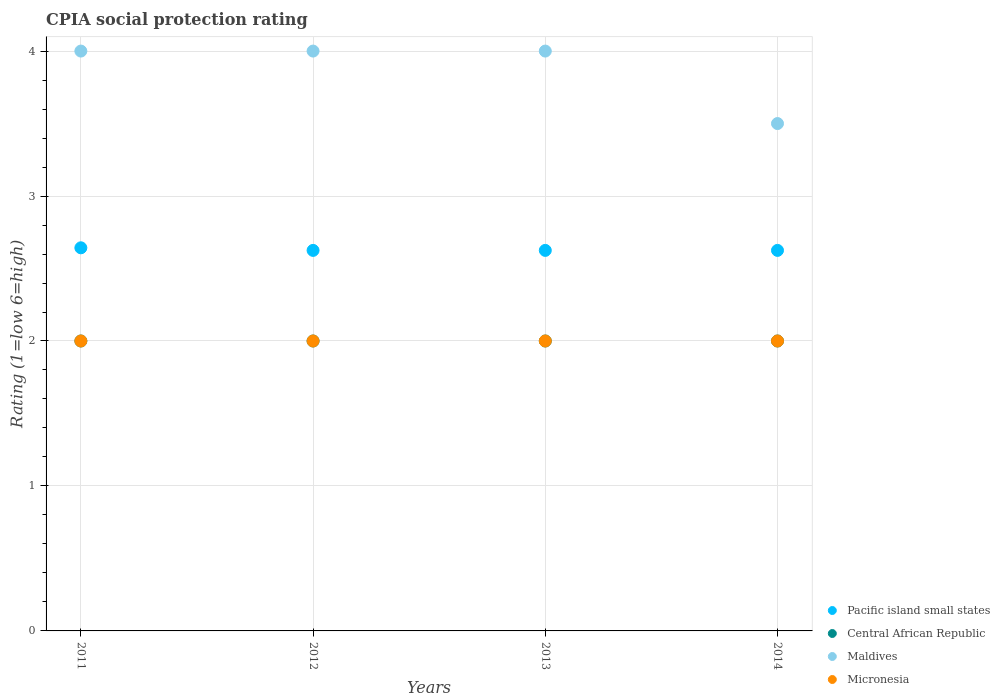How many different coloured dotlines are there?
Make the answer very short. 4. What is the CPIA rating in Micronesia in 2012?
Offer a terse response. 2. Across all years, what is the maximum CPIA rating in Central African Republic?
Make the answer very short. 2. In which year was the CPIA rating in Maldives minimum?
Ensure brevity in your answer.  2014. What is the difference between the CPIA rating in Central African Republic in 2012 and that in 2014?
Keep it short and to the point. 0. What is the difference between the CPIA rating in Micronesia in 2011 and the CPIA rating in Pacific island small states in 2012?
Provide a short and direct response. -0.62. What is the average CPIA rating in Central African Republic per year?
Your response must be concise. 2. In the year 2014, what is the difference between the CPIA rating in Micronesia and CPIA rating in Pacific island small states?
Ensure brevity in your answer.  -0.62. In how many years, is the CPIA rating in Pacific island small states greater than 1.4?
Provide a short and direct response. 4. What is the ratio of the CPIA rating in Micronesia in 2012 to that in 2014?
Make the answer very short. 1. Is the CPIA rating in Central African Republic in 2011 less than that in 2013?
Provide a short and direct response. No. What is the difference between the highest and the second highest CPIA rating in Central African Republic?
Your response must be concise. 0. In how many years, is the CPIA rating in Maldives greater than the average CPIA rating in Maldives taken over all years?
Make the answer very short. 3. Is it the case that in every year, the sum of the CPIA rating in Central African Republic and CPIA rating in Micronesia  is greater than the sum of CPIA rating in Pacific island small states and CPIA rating in Maldives?
Give a very brief answer. No. Is it the case that in every year, the sum of the CPIA rating in Pacific island small states and CPIA rating in Central African Republic  is greater than the CPIA rating in Micronesia?
Your answer should be compact. Yes. Is the CPIA rating in Micronesia strictly greater than the CPIA rating in Pacific island small states over the years?
Offer a terse response. No. How many dotlines are there?
Provide a short and direct response. 4. Does the graph contain grids?
Offer a very short reply. Yes. Where does the legend appear in the graph?
Make the answer very short. Bottom right. How are the legend labels stacked?
Offer a very short reply. Vertical. What is the title of the graph?
Your answer should be very brief. CPIA social protection rating. What is the label or title of the Y-axis?
Provide a short and direct response. Rating (1=low 6=high). What is the Rating (1=low 6=high) of Pacific island small states in 2011?
Your answer should be very brief. 2.64. What is the Rating (1=low 6=high) of Central African Republic in 2011?
Keep it short and to the point. 2. What is the Rating (1=low 6=high) of Maldives in 2011?
Offer a terse response. 4. What is the Rating (1=low 6=high) of Micronesia in 2011?
Make the answer very short. 2. What is the Rating (1=low 6=high) in Pacific island small states in 2012?
Keep it short and to the point. 2.62. What is the Rating (1=low 6=high) of Central African Republic in 2012?
Give a very brief answer. 2. What is the Rating (1=low 6=high) in Pacific island small states in 2013?
Your answer should be very brief. 2.62. What is the Rating (1=low 6=high) of Micronesia in 2013?
Keep it short and to the point. 2. What is the Rating (1=low 6=high) of Pacific island small states in 2014?
Your response must be concise. 2.62. What is the Rating (1=low 6=high) in Micronesia in 2014?
Offer a terse response. 2. Across all years, what is the maximum Rating (1=low 6=high) in Pacific island small states?
Make the answer very short. 2.64. Across all years, what is the minimum Rating (1=low 6=high) of Pacific island small states?
Give a very brief answer. 2.62. Across all years, what is the minimum Rating (1=low 6=high) in Central African Republic?
Offer a very short reply. 2. Across all years, what is the minimum Rating (1=low 6=high) in Micronesia?
Your answer should be very brief. 2. What is the total Rating (1=low 6=high) of Pacific island small states in the graph?
Make the answer very short. 10.52. What is the difference between the Rating (1=low 6=high) in Pacific island small states in 2011 and that in 2012?
Make the answer very short. 0.02. What is the difference between the Rating (1=low 6=high) of Maldives in 2011 and that in 2012?
Offer a very short reply. 0. What is the difference between the Rating (1=low 6=high) of Micronesia in 2011 and that in 2012?
Ensure brevity in your answer.  0. What is the difference between the Rating (1=low 6=high) in Pacific island small states in 2011 and that in 2013?
Your answer should be very brief. 0.02. What is the difference between the Rating (1=low 6=high) of Central African Republic in 2011 and that in 2013?
Make the answer very short. 0. What is the difference between the Rating (1=low 6=high) of Pacific island small states in 2011 and that in 2014?
Make the answer very short. 0.02. What is the difference between the Rating (1=low 6=high) of Micronesia in 2011 and that in 2014?
Keep it short and to the point. 0. What is the difference between the Rating (1=low 6=high) of Central African Republic in 2012 and that in 2013?
Offer a terse response. 0. What is the difference between the Rating (1=low 6=high) of Maldives in 2012 and that in 2013?
Your response must be concise. 0. What is the difference between the Rating (1=low 6=high) of Micronesia in 2012 and that in 2013?
Offer a terse response. 0. What is the difference between the Rating (1=low 6=high) in Central African Republic in 2012 and that in 2014?
Offer a very short reply. 0. What is the difference between the Rating (1=low 6=high) in Micronesia in 2013 and that in 2014?
Keep it short and to the point. 0. What is the difference between the Rating (1=low 6=high) in Pacific island small states in 2011 and the Rating (1=low 6=high) in Central African Republic in 2012?
Give a very brief answer. 0.64. What is the difference between the Rating (1=low 6=high) in Pacific island small states in 2011 and the Rating (1=low 6=high) in Maldives in 2012?
Provide a succinct answer. -1.36. What is the difference between the Rating (1=low 6=high) of Pacific island small states in 2011 and the Rating (1=low 6=high) of Micronesia in 2012?
Make the answer very short. 0.64. What is the difference between the Rating (1=low 6=high) in Central African Republic in 2011 and the Rating (1=low 6=high) in Maldives in 2012?
Offer a very short reply. -2. What is the difference between the Rating (1=low 6=high) of Pacific island small states in 2011 and the Rating (1=low 6=high) of Central African Republic in 2013?
Offer a terse response. 0.64. What is the difference between the Rating (1=low 6=high) in Pacific island small states in 2011 and the Rating (1=low 6=high) in Maldives in 2013?
Keep it short and to the point. -1.36. What is the difference between the Rating (1=low 6=high) in Pacific island small states in 2011 and the Rating (1=low 6=high) in Micronesia in 2013?
Offer a terse response. 0.64. What is the difference between the Rating (1=low 6=high) in Central African Republic in 2011 and the Rating (1=low 6=high) in Micronesia in 2013?
Give a very brief answer. 0. What is the difference between the Rating (1=low 6=high) in Maldives in 2011 and the Rating (1=low 6=high) in Micronesia in 2013?
Make the answer very short. 2. What is the difference between the Rating (1=low 6=high) in Pacific island small states in 2011 and the Rating (1=low 6=high) in Central African Republic in 2014?
Provide a short and direct response. 0.64. What is the difference between the Rating (1=low 6=high) in Pacific island small states in 2011 and the Rating (1=low 6=high) in Maldives in 2014?
Your answer should be very brief. -0.86. What is the difference between the Rating (1=low 6=high) in Pacific island small states in 2011 and the Rating (1=low 6=high) in Micronesia in 2014?
Offer a terse response. 0.64. What is the difference between the Rating (1=low 6=high) in Maldives in 2011 and the Rating (1=low 6=high) in Micronesia in 2014?
Provide a succinct answer. 2. What is the difference between the Rating (1=low 6=high) in Pacific island small states in 2012 and the Rating (1=low 6=high) in Maldives in 2013?
Give a very brief answer. -1.38. What is the difference between the Rating (1=low 6=high) in Central African Republic in 2012 and the Rating (1=low 6=high) in Micronesia in 2013?
Offer a terse response. 0. What is the difference between the Rating (1=low 6=high) in Maldives in 2012 and the Rating (1=low 6=high) in Micronesia in 2013?
Keep it short and to the point. 2. What is the difference between the Rating (1=low 6=high) in Pacific island small states in 2012 and the Rating (1=low 6=high) in Maldives in 2014?
Give a very brief answer. -0.88. What is the difference between the Rating (1=low 6=high) of Central African Republic in 2012 and the Rating (1=low 6=high) of Maldives in 2014?
Ensure brevity in your answer.  -1.5. What is the difference between the Rating (1=low 6=high) of Central African Republic in 2012 and the Rating (1=low 6=high) of Micronesia in 2014?
Keep it short and to the point. 0. What is the difference between the Rating (1=low 6=high) of Maldives in 2012 and the Rating (1=low 6=high) of Micronesia in 2014?
Offer a very short reply. 2. What is the difference between the Rating (1=low 6=high) in Pacific island small states in 2013 and the Rating (1=low 6=high) in Maldives in 2014?
Provide a short and direct response. -0.88. What is the difference between the Rating (1=low 6=high) of Pacific island small states in 2013 and the Rating (1=low 6=high) of Micronesia in 2014?
Keep it short and to the point. 0.62. What is the difference between the Rating (1=low 6=high) of Central African Republic in 2013 and the Rating (1=low 6=high) of Maldives in 2014?
Your response must be concise. -1.5. What is the average Rating (1=low 6=high) in Pacific island small states per year?
Offer a very short reply. 2.63. What is the average Rating (1=low 6=high) of Central African Republic per year?
Offer a very short reply. 2. What is the average Rating (1=low 6=high) in Maldives per year?
Offer a very short reply. 3.88. What is the average Rating (1=low 6=high) of Micronesia per year?
Your response must be concise. 2. In the year 2011, what is the difference between the Rating (1=low 6=high) in Pacific island small states and Rating (1=low 6=high) in Central African Republic?
Provide a short and direct response. 0.64. In the year 2011, what is the difference between the Rating (1=low 6=high) of Pacific island small states and Rating (1=low 6=high) of Maldives?
Provide a short and direct response. -1.36. In the year 2011, what is the difference between the Rating (1=low 6=high) of Pacific island small states and Rating (1=low 6=high) of Micronesia?
Your response must be concise. 0.64. In the year 2011, what is the difference between the Rating (1=low 6=high) of Central African Republic and Rating (1=low 6=high) of Micronesia?
Provide a succinct answer. 0. In the year 2012, what is the difference between the Rating (1=low 6=high) of Pacific island small states and Rating (1=low 6=high) of Maldives?
Provide a short and direct response. -1.38. In the year 2012, what is the difference between the Rating (1=low 6=high) in Pacific island small states and Rating (1=low 6=high) in Micronesia?
Your answer should be very brief. 0.62. In the year 2012, what is the difference between the Rating (1=low 6=high) in Central African Republic and Rating (1=low 6=high) in Micronesia?
Your response must be concise. 0. In the year 2012, what is the difference between the Rating (1=low 6=high) of Maldives and Rating (1=low 6=high) of Micronesia?
Provide a short and direct response. 2. In the year 2013, what is the difference between the Rating (1=low 6=high) in Pacific island small states and Rating (1=low 6=high) in Maldives?
Keep it short and to the point. -1.38. In the year 2013, what is the difference between the Rating (1=low 6=high) of Pacific island small states and Rating (1=low 6=high) of Micronesia?
Offer a terse response. 0.62. In the year 2013, what is the difference between the Rating (1=low 6=high) of Central African Republic and Rating (1=low 6=high) of Maldives?
Give a very brief answer. -2. In the year 2013, what is the difference between the Rating (1=low 6=high) in Maldives and Rating (1=low 6=high) in Micronesia?
Make the answer very short. 2. In the year 2014, what is the difference between the Rating (1=low 6=high) of Pacific island small states and Rating (1=low 6=high) of Maldives?
Offer a very short reply. -0.88. In the year 2014, what is the difference between the Rating (1=low 6=high) of Pacific island small states and Rating (1=low 6=high) of Micronesia?
Give a very brief answer. 0.62. In the year 2014, what is the difference between the Rating (1=low 6=high) of Central African Republic and Rating (1=low 6=high) of Maldives?
Your answer should be very brief. -1.5. What is the ratio of the Rating (1=low 6=high) in Pacific island small states in 2011 to that in 2012?
Provide a succinct answer. 1.01. What is the ratio of the Rating (1=low 6=high) in Central African Republic in 2011 to that in 2012?
Give a very brief answer. 1. What is the ratio of the Rating (1=low 6=high) of Micronesia in 2011 to that in 2012?
Your response must be concise. 1. What is the ratio of the Rating (1=low 6=high) in Pacific island small states in 2011 to that in 2013?
Ensure brevity in your answer.  1.01. What is the ratio of the Rating (1=low 6=high) in Micronesia in 2011 to that in 2013?
Make the answer very short. 1. What is the ratio of the Rating (1=low 6=high) in Pacific island small states in 2011 to that in 2014?
Provide a short and direct response. 1.01. What is the ratio of the Rating (1=low 6=high) in Maldives in 2011 to that in 2014?
Offer a very short reply. 1.14. What is the ratio of the Rating (1=low 6=high) of Pacific island small states in 2012 to that in 2013?
Offer a terse response. 1. What is the ratio of the Rating (1=low 6=high) of Central African Republic in 2012 to that in 2013?
Provide a succinct answer. 1. What is the ratio of the Rating (1=low 6=high) of Maldives in 2012 to that in 2013?
Keep it short and to the point. 1. What is the ratio of the Rating (1=low 6=high) in Pacific island small states in 2012 to that in 2014?
Keep it short and to the point. 1. What is the ratio of the Rating (1=low 6=high) in Micronesia in 2012 to that in 2014?
Offer a very short reply. 1. What is the ratio of the Rating (1=low 6=high) in Pacific island small states in 2013 to that in 2014?
Ensure brevity in your answer.  1. What is the difference between the highest and the second highest Rating (1=low 6=high) in Pacific island small states?
Provide a short and direct response. 0.02. What is the difference between the highest and the second highest Rating (1=low 6=high) in Central African Republic?
Keep it short and to the point. 0. What is the difference between the highest and the lowest Rating (1=low 6=high) of Pacific island small states?
Ensure brevity in your answer.  0.02. What is the difference between the highest and the lowest Rating (1=low 6=high) of Micronesia?
Give a very brief answer. 0. 